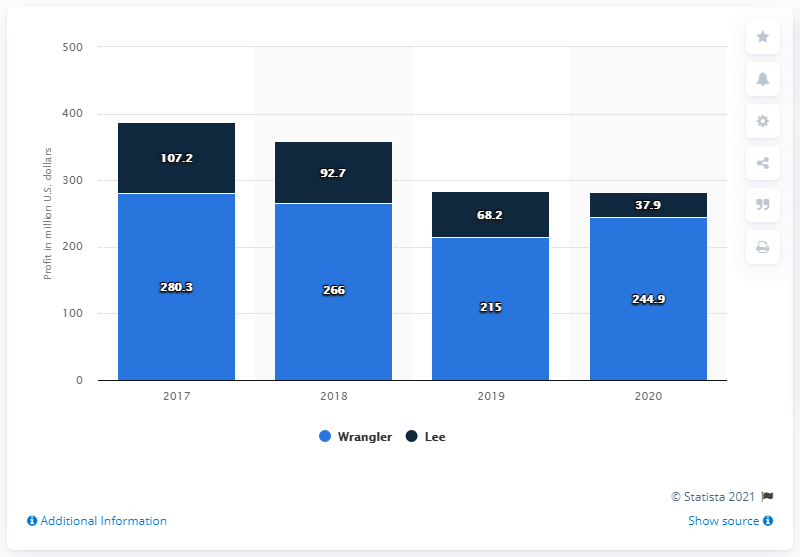Give some essential details in this illustration. The Wrangler brand made $244.9 million in the U.S. in 2020. 